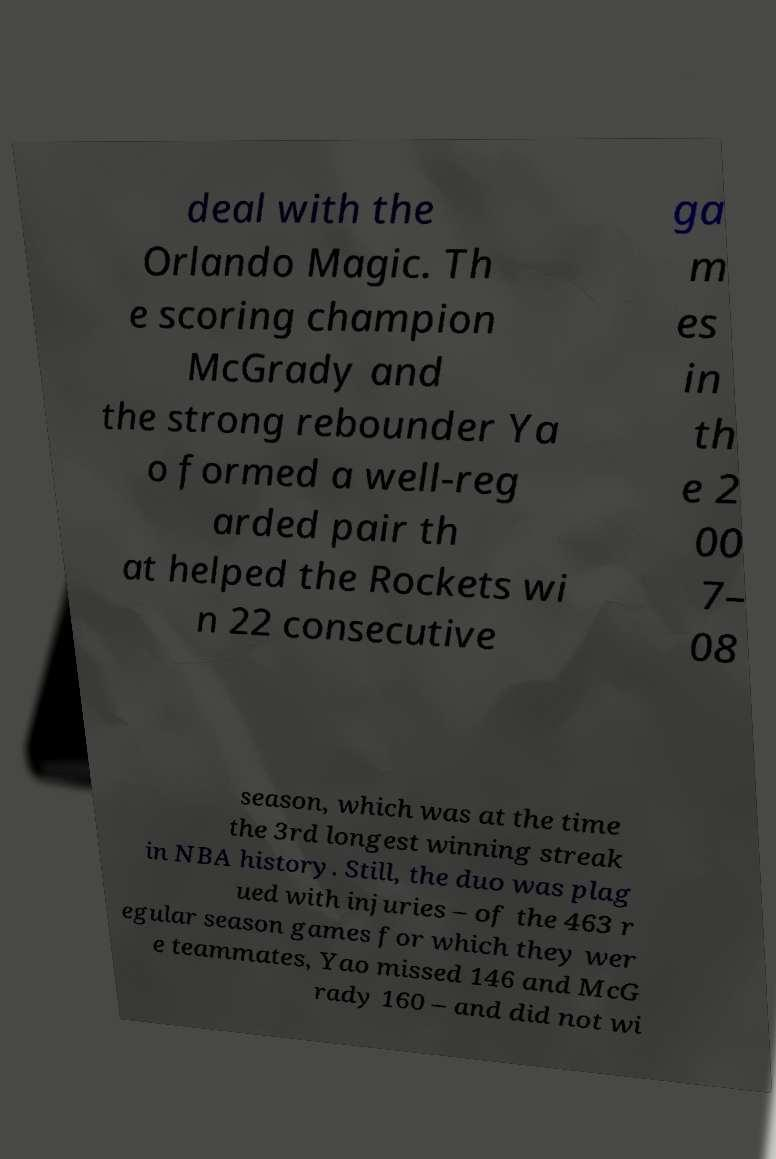I need the written content from this picture converted into text. Can you do that? deal with the Orlando Magic. Th e scoring champion McGrady and the strong rebounder Ya o formed a well-reg arded pair th at helped the Rockets wi n 22 consecutive ga m es in th e 2 00 7– 08 season, which was at the time the 3rd longest winning streak in NBA history. Still, the duo was plag ued with injuries – of the 463 r egular season games for which they wer e teammates, Yao missed 146 and McG rady 160 – and did not wi 